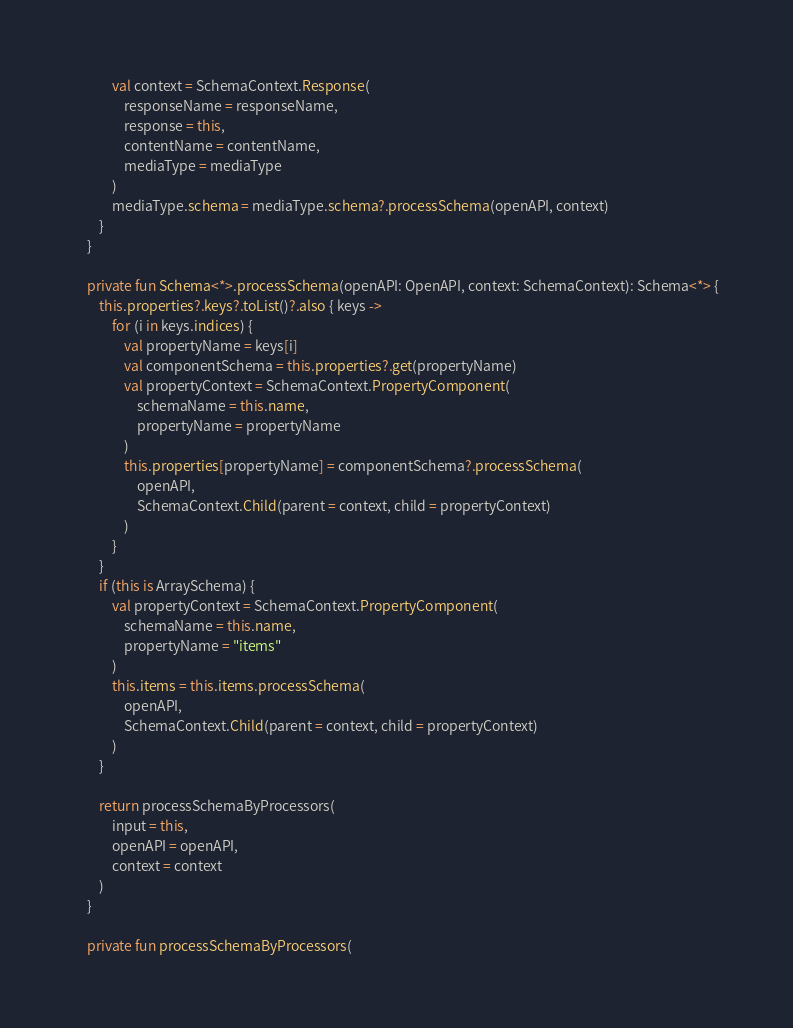<code> <loc_0><loc_0><loc_500><loc_500><_Kotlin_>            val context = SchemaContext.Response(
                responseName = responseName,
                response = this,
                contentName = contentName,
                mediaType = mediaType
            )
            mediaType.schema = mediaType.schema?.processSchema(openAPI, context)
        }
    }

    private fun Schema<*>.processSchema(openAPI: OpenAPI, context: SchemaContext): Schema<*> {
        this.properties?.keys?.toList()?.also { keys ->
            for (i in keys.indices) {
                val propertyName = keys[i]
                val componentSchema = this.properties?.get(propertyName)
                val propertyContext = SchemaContext.PropertyComponent(
                    schemaName = this.name,
                    propertyName = propertyName
                )
                this.properties[propertyName] = componentSchema?.processSchema(
                    openAPI,
                    SchemaContext.Child(parent = context, child = propertyContext)
                )
            }
        }
        if (this is ArraySchema) {
            val propertyContext = SchemaContext.PropertyComponent(
                schemaName = this.name,
                propertyName = "items"
            )
            this.items = this.items.processSchema(
                openAPI,
                SchemaContext.Child(parent = context, child = propertyContext)
            )
        }

        return processSchemaByProcessors(
            input = this,
            openAPI = openAPI,
            context = context
        )
    }

    private fun processSchemaByProcessors(</code> 